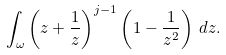Convert formula to latex. <formula><loc_0><loc_0><loc_500><loc_500>\int _ { \omega } \left ( z + \frac { 1 } { z } \right ) ^ { j - 1 } \left ( 1 - \frac { 1 } { z ^ { 2 } } \right ) \, d z .</formula> 